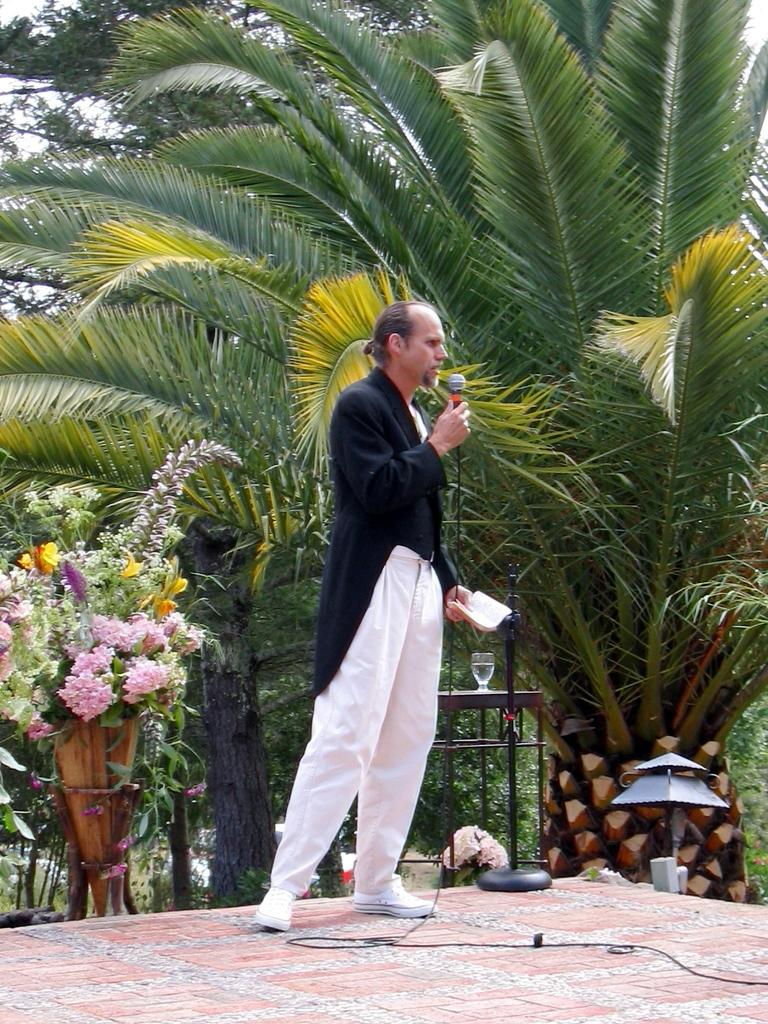What is the man in the image holding? The man is holding a microphone. What can be found near the man in the image? There is a vase, flowers, a glass, and a chair in the image. What is the background of the image? There are trees and the sky are visible in the background of the image. Can you see a beggar asking for money in the image? There is no beggar asking for money in the image. Is there a stream visible in the background of the image? There is no stream present in the image; only trees and the sky are visible in the background. 